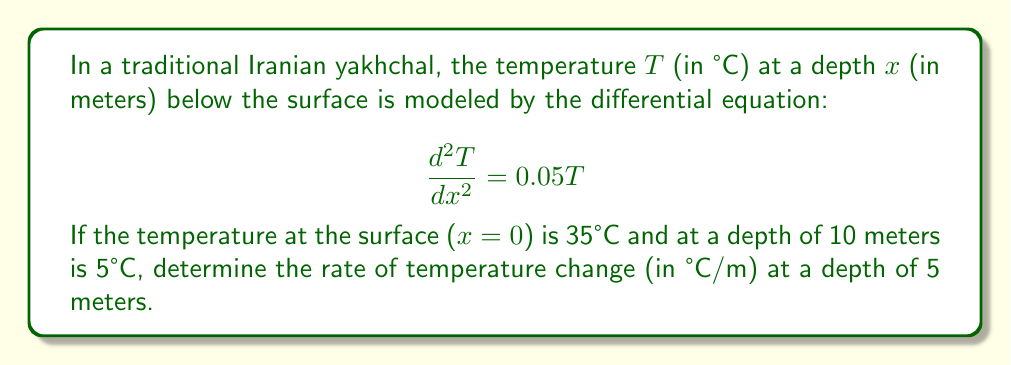Can you solve this math problem? Let's solve this step-by-step:

1) The general solution to the differential equation $\frac{d^2T}{dx^2} = 0.05T$ is:

   $$T(x) = C_1e^{\sqrt{0.05}x} + C_2e^{-\sqrt{0.05}x}$$

   Where $C_1$ and $C_2$ are constants we need to determine.

2) We have two boundary conditions:
   - At $x=0$, $T=35$
   - At $x=10$, $T=5$

3) Let's use these to find $C_1$ and $C_2$:

   For $x=0$: $35 = C_1 + C_2$
   For $x=10$: $5 = C_1e^{\sqrt{0.05}(10)} + C_2e^{-\sqrt{0.05}(10)}$

4) Let $a = e^{\sqrt{0.05}(10)} \approx 9.0484$ for simplicity. Then our equations are:

   $35 = C_1 + C_2$
   $5 = C_1a + C_2/a$

5) Solving this system:

   $C_1 = \frac{35/a - 5}{1/a - a} \approx 39.7731$
   $C_2 = 35 - C_1 \approx -4.7731$

6) Now we have our temperature function:

   $$T(x) = 39.7731e^{\sqrt{0.05}x} - 4.7731e^{-\sqrt{0.05}x}$$

7) To find the rate of change at $x=5$, we need to differentiate this and evaluate at $x=5$:

   $$\frac{dT}{dx} = 39.7731\sqrt{0.05}e^{\sqrt{0.05}x} + 4.7731\sqrt{0.05}e^{-\sqrt{0.05}x}$$

8) Evaluating at $x=5$:

   $$\left.\frac{dT}{dx}\right|_{x=5} = 39.7731\sqrt{0.05}e^{\sqrt{0.05}(5)} + 4.7731\sqrt{0.05}e^{-\sqrt{0.05}(5)}$$

9) Calculating this value:

   $$\left.\frac{dT}{dx}\right|_{x=5} \approx -3.0075 \text{ °C/m}$$
Answer: The rate of temperature change at a depth of 5 meters in the yakhchal is approximately -3.0075 °C/m. 